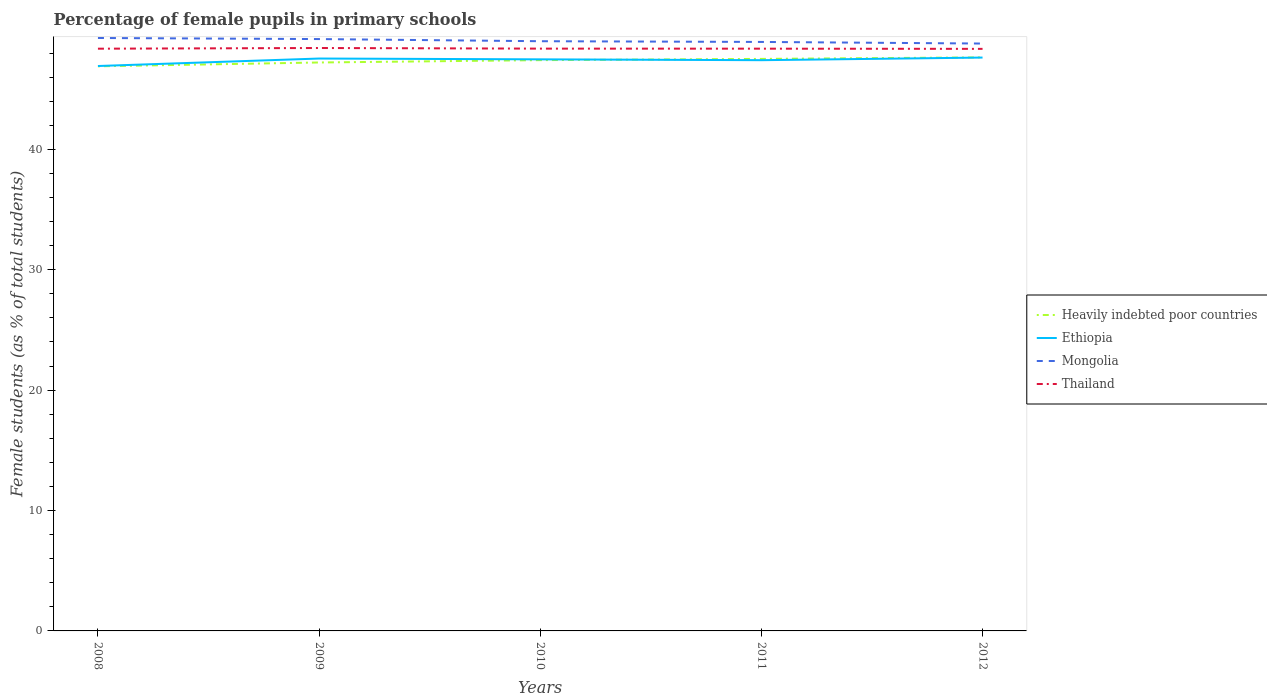Does the line corresponding to Heavily indebted poor countries intersect with the line corresponding to Ethiopia?
Offer a terse response. Yes. Across all years, what is the maximum percentage of female pupils in primary schools in Mongolia?
Make the answer very short. 48.79. In which year was the percentage of female pupils in primary schools in Heavily indebted poor countries maximum?
Make the answer very short. 2008. What is the total percentage of female pupils in primary schools in Heavily indebted poor countries in the graph?
Your answer should be compact. -0.32. What is the difference between the highest and the second highest percentage of female pupils in primary schools in Mongolia?
Offer a terse response. 0.46. What is the difference between the highest and the lowest percentage of female pupils in primary schools in Thailand?
Offer a terse response. 1. How many lines are there?
Provide a succinct answer. 4. Does the graph contain any zero values?
Make the answer very short. No. Does the graph contain grids?
Your response must be concise. No. How are the legend labels stacked?
Keep it short and to the point. Vertical. What is the title of the graph?
Offer a terse response. Percentage of female pupils in primary schools. What is the label or title of the Y-axis?
Provide a succinct answer. Female students (as % of total students). What is the Female students (as % of total students) in Heavily indebted poor countries in 2008?
Offer a very short reply. 46.89. What is the Female students (as % of total students) in Ethiopia in 2008?
Make the answer very short. 46.92. What is the Female students (as % of total students) in Mongolia in 2008?
Keep it short and to the point. 49.25. What is the Female students (as % of total students) of Thailand in 2008?
Offer a very short reply. 48.36. What is the Female students (as % of total students) in Heavily indebted poor countries in 2009?
Your answer should be compact. 47.21. What is the Female students (as % of total students) in Ethiopia in 2009?
Your answer should be very brief. 47.54. What is the Female students (as % of total students) in Mongolia in 2009?
Offer a terse response. 49.16. What is the Female students (as % of total students) of Thailand in 2009?
Offer a very short reply. 48.41. What is the Female students (as % of total students) of Heavily indebted poor countries in 2010?
Provide a short and direct response. 47.41. What is the Female students (as % of total students) of Ethiopia in 2010?
Give a very brief answer. 47.47. What is the Female students (as % of total students) of Mongolia in 2010?
Give a very brief answer. 48.98. What is the Female students (as % of total students) in Thailand in 2010?
Keep it short and to the point. 48.36. What is the Female students (as % of total students) in Heavily indebted poor countries in 2011?
Keep it short and to the point. 47.51. What is the Female students (as % of total students) in Ethiopia in 2011?
Make the answer very short. 47.4. What is the Female students (as % of total students) of Mongolia in 2011?
Offer a terse response. 48.92. What is the Female students (as % of total students) in Thailand in 2011?
Provide a short and direct response. 48.36. What is the Female students (as % of total students) in Heavily indebted poor countries in 2012?
Keep it short and to the point. 47.64. What is the Female students (as % of total students) in Ethiopia in 2012?
Your response must be concise. 47.62. What is the Female students (as % of total students) of Mongolia in 2012?
Offer a terse response. 48.79. What is the Female students (as % of total students) in Thailand in 2012?
Your response must be concise. 48.34. Across all years, what is the maximum Female students (as % of total students) of Heavily indebted poor countries?
Offer a terse response. 47.64. Across all years, what is the maximum Female students (as % of total students) in Ethiopia?
Your response must be concise. 47.62. Across all years, what is the maximum Female students (as % of total students) of Mongolia?
Give a very brief answer. 49.25. Across all years, what is the maximum Female students (as % of total students) of Thailand?
Provide a succinct answer. 48.41. Across all years, what is the minimum Female students (as % of total students) of Heavily indebted poor countries?
Your answer should be compact. 46.89. Across all years, what is the minimum Female students (as % of total students) of Ethiopia?
Offer a terse response. 46.92. Across all years, what is the minimum Female students (as % of total students) in Mongolia?
Keep it short and to the point. 48.79. Across all years, what is the minimum Female students (as % of total students) of Thailand?
Your answer should be compact. 48.34. What is the total Female students (as % of total students) in Heavily indebted poor countries in the graph?
Make the answer very short. 236.66. What is the total Female students (as % of total students) in Ethiopia in the graph?
Provide a short and direct response. 236.96. What is the total Female students (as % of total students) in Mongolia in the graph?
Make the answer very short. 245.09. What is the total Female students (as % of total students) of Thailand in the graph?
Your answer should be compact. 241.84. What is the difference between the Female students (as % of total students) in Heavily indebted poor countries in 2008 and that in 2009?
Provide a succinct answer. -0.32. What is the difference between the Female students (as % of total students) of Ethiopia in 2008 and that in 2009?
Keep it short and to the point. -0.62. What is the difference between the Female students (as % of total students) in Mongolia in 2008 and that in 2009?
Your answer should be very brief. 0.09. What is the difference between the Female students (as % of total students) in Thailand in 2008 and that in 2009?
Keep it short and to the point. -0.06. What is the difference between the Female students (as % of total students) of Heavily indebted poor countries in 2008 and that in 2010?
Offer a terse response. -0.51. What is the difference between the Female students (as % of total students) in Ethiopia in 2008 and that in 2010?
Make the answer very short. -0.55. What is the difference between the Female students (as % of total students) of Mongolia in 2008 and that in 2010?
Your response must be concise. 0.27. What is the difference between the Female students (as % of total students) of Thailand in 2008 and that in 2010?
Make the answer very short. -0.01. What is the difference between the Female students (as % of total students) of Heavily indebted poor countries in 2008 and that in 2011?
Provide a succinct answer. -0.62. What is the difference between the Female students (as % of total students) in Ethiopia in 2008 and that in 2011?
Provide a succinct answer. -0.48. What is the difference between the Female students (as % of total students) of Mongolia in 2008 and that in 2011?
Offer a terse response. 0.33. What is the difference between the Female students (as % of total students) in Thailand in 2008 and that in 2011?
Provide a short and direct response. -0. What is the difference between the Female students (as % of total students) in Heavily indebted poor countries in 2008 and that in 2012?
Provide a short and direct response. -0.74. What is the difference between the Female students (as % of total students) of Ethiopia in 2008 and that in 2012?
Offer a very short reply. -0.7. What is the difference between the Female students (as % of total students) of Mongolia in 2008 and that in 2012?
Your response must be concise. 0.46. What is the difference between the Female students (as % of total students) in Thailand in 2008 and that in 2012?
Keep it short and to the point. 0.01. What is the difference between the Female students (as % of total students) in Heavily indebted poor countries in 2009 and that in 2010?
Give a very brief answer. -0.19. What is the difference between the Female students (as % of total students) in Ethiopia in 2009 and that in 2010?
Your answer should be compact. 0.07. What is the difference between the Female students (as % of total students) in Mongolia in 2009 and that in 2010?
Keep it short and to the point. 0.18. What is the difference between the Female students (as % of total students) of Thailand in 2009 and that in 2010?
Your answer should be compact. 0.05. What is the difference between the Female students (as % of total students) in Heavily indebted poor countries in 2009 and that in 2011?
Your answer should be very brief. -0.3. What is the difference between the Female students (as % of total students) of Ethiopia in 2009 and that in 2011?
Make the answer very short. 0.14. What is the difference between the Female students (as % of total students) in Mongolia in 2009 and that in 2011?
Offer a terse response. 0.24. What is the difference between the Female students (as % of total students) in Thailand in 2009 and that in 2011?
Provide a succinct answer. 0.05. What is the difference between the Female students (as % of total students) of Heavily indebted poor countries in 2009 and that in 2012?
Your answer should be very brief. -0.42. What is the difference between the Female students (as % of total students) of Ethiopia in 2009 and that in 2012?
Ensure brevity in your answer.  -0.08. What is the difference between the Female students (as % of total students) in Mongolia in 2009 and that in 2012?
Give a very brief answer. 0.37. What is the difference between the Female students (as % of total students) in Thailand in 2009 and that in 2012?
Your response must be concise. 0.07. What is the difference between the Female students (as % of total students) in Heavily indebted poor countries in 2010 and that in 2011?
Offer a very short reply. -0.1. What is the difference between the Female students (as % of total students) of Ethiopia in 2010 and that in 2011?
Your response must be concise. 0.07. What is the difference between the Female students (as % of total students) of Thailand in 2010 and that in 2011?
Your answer should be compact. 0. What is the difference between the Female students (as % of total students) of Heavily indebted poor countries in 2010 and that in 2012?
Keep it short and to the point. -0.23. What is the difference between the Female students (as % of total students) of Ethiopia in 2010 and that in 2012?
Provide a succinct answer. -0.15. What is the difference between the Female students (as % of total students) of Mongolia in 2010 and that in 2012?
Provide a succinct answer. 0.19. What is the difference between the Female students (as % of total students) in Thailand in 2010 and that in 2012?
Your response must be concise. 0.02. What is the difference between the Female students (as % of total students) of Heavily indebted poor countries in 2011 and that in 2012?
Offer a very short reply. -0.13. What is the difference between the Female students (as % of total students) in Ethiopia in 2011 and that in 2012?
Keep it short and to the point. -0.22. What is the difference between the Female students (as % of total students) in Mongolia in 2011 and that in 2012?
Your answer should be compact. 0.13. What is the difference between the Female students (as % of total students) in Thailand in 2011 and that in 2012?
Make the answer very short. 0.02. What is the difference between the Female students (as % of total students) of Heavily indebted poor countries in 2008 and the Female students (as % of total students) of Ethiopia in 2009?
Give a very brief answer. -0.65. What is the difference between the Female students (as % of total students) in Heavily indebted poor countries in 2008 and the Female students (as % of total students) in Mongolia in 2009?
Make the answer very short. -2.26. What is the difference between the Female students (as % of total students) of Heavily indebted poor countries in 2008 and the Female students (as % of total students) of Thailand in 2009?
Offer a very short reply. -1.52. What is the difference between the Female students (as % of total students) in Ethiopia in 2008 and the Female students (as % of total students) in Mongolia in 2009?
Provide a short and direct response. -2.24. What is the difference between the Female students (as % of total students) of Ethiopia in 2008 and the Female students (as % of total students) of Thailand in 2009?
Your answer should be compact. -1.5. What is the difference between the Female students (as % of total students) in Mongolia in 2008 and the Female students (as % of total students) in Thailand in 2009?
Your answer should be compact. 0.83. What is the difference between the Female students (as % of total students) in Heavily indebted poor countries in 2008 and the Female students (as % of total students) in Ethiopia in 2010?
Offer a very short reply. -0.58. What is the difference between the Female students (as % of total students) in Heavily indebted poor countries in 2008 and the Female students (as % of total students) in Mongolia in 2010?
Your response must be concise. -2.08. What is the difference between the Female students (as % of total students) of Heavily indebted poor countries in 2008 and the Female students (as % of total students) of Thailand in 2010?
Keep it short and to the point. -1.47. What is the difference between the Female students (as % of total students) of Ethiopia in 2008 and the Female students (as % of total students) of Mongolia in 2010?
Provide a succinct answer. -2.06. What is the difference between the Female students (as % of total students) of Ethiopia in 2008 and the Female students (as % of total students) of Thailand in 2010?
Provide a succinct answer. -1.44. What is the difference between the Female students (as % of total students) of Mongolia in 2008 and the Female students (as % of total students) of Thailand in 2010?
Give a very brief answer. 0.88. What is the difference between the Female students (as % of total students) in Heavily indebted poor countries in 2008 and the Female students (as % of total students) in Ethiopia in 2011?
Offer a very short reply. -0.51. What is the difference between the Female students (as % of total students) in Heavily indebted poor countries in 2008 and the Female students (as % of total students) in Mongolia in 2011?
Provide a short and direct response. -2.02. What is the difference between the Female students (as % of total students) in Heavily indebted poor countries in 2008 and the Female students (as % of total students) in Thailand in 2011?
Offer a terse response. -1.47. What is the difference between the Female students (as % of total students) of Ethiopia in 2008 and the Female students (as % of total students) of Mongolia in 2011?
Your answer should be very brief. -2. What is the difference between the Female students (as % of total students) of Ethiopia in 2008 and the Female students (as % of total students) of Thailand in 2011?
Give a very brief answer. -1.44. What is the difference between the Female students (as % of total students) of Mongolia in 2008 and the Female students (as % of total students) of Thailand in 2011?
Your answer should be compact. 0.89. What is the difference between the Female students (as % of total students) of Heavily indebted poor countries in 2008 and the Female students (as % of total students) of Ethiopia in 2012?
Ensure brevity in your answer.  -0.73. What is the difference between the Female students (as % of total students) in Heavily indebted poor countries in 2008 and the Female students (as % of total students) in Mongolia in 2012?
Offer a very short reply. -1.89. What is the difference between the Female students (as % of total students) of Heavily indebted poor countries in 2008 and the Female students (as % of total students) of Thailand in 2012?
Your response must be concise. -1.45. What is the difference between the Female students (as % of total students) of Ethiopia in 2008 and the Female students (as % of total students) of Mongolia in 2012?
Make the answer very short. -1.87. What is the difference between the Female students (as % of total students) of Ethiopia in 2008 and the Female students (as % of total students) of Thailand in 2012?
Your answer should be very brief. -1.42. What is the difference between the Female students (as % of total students) in Mongolia in 2008 and the Female students (as % of total students) in Thailand in 2012?
Keep it short and to the point. 0.9. What is the difference between the Female students (as % of total students) in Heavily indebted poor countries in 2009 and the Female students (as % of total students) in Ethiopia in 2010?
Make the answer very short. -0.26. What is the difference between the Female students (as % of total students) of Heavily indebted poor countries in 2009 and the Female students (as % of total students) of Mongolia in 2010?
Give a very brief answer. -1.77. What is the difference between the Female students (as % of total students) of Heavily indebted poor countries in 2009 and the Female students (as % of total students) of Thailand in 2010?
Your response must be concise. -1.15. What is the difference between the Female students (as % of total students) in Ethiopia in 2009 and the Female students (as % of total students) in Mongolia in 2010?
Your answer should be very brief. -1.44. What is the difference between the Female students (as % of total students) of Ethiopia in 2009 and the Female students (as % of total students) of Thailand in 2010?
Your answer should be compact. -0.82. What is the difference between the Female students (as % of total students) of Mongolia in 2009 and the Female students (as % of total students) of Thailand in 2010?
Provide a short and direct response. 0.79. What is the difference between the Female students (as % of total students) of Heavily indebted poor countries in 2009 and the Female students (as % of total students) of Ethiopia in 2011?
Your answer should be very brief. -0.19. What is the difference between the Female students (as % of total students) in Heavily indebted poor countries in 2009 and the Female students (as % of total students) in Mongolia in 2011?
Ensure brevity in your answer.  -1.71. What is the difference between the Female students (as % of total students) in Heavily indebted poor countries in 2009 and the Female students (as % of total students) in Thailand in 2011?
Your answer should be very brief. -1.15. What is the difference between the Female students (as % of total students) of Ethiopia in 2009 and the Female students (as % of total students) of Mongolia in 2011?
Your response must be concise. -1.38. What is the difference between the Female students (as % of total students) in Ethiopia in 2009 and the Female students (as % of total students) in Thailand in 2011?
Make the answer very short. -0.82. What is the difference between the Female students (as % of total students) in Mongolia in 2009 and the Female students (as % of total students) in Thailand in 2011?
Offer a terse response. 0.8. What is the difference between the Female students (as % of total students) of Heavily indebted poor countries in 2009 and the Female students (as % of total students) of Ethiopia in 2012?
Your answer should be very brief. -0.41. What is the difference between the Female students (as % of total students) of Heavily indebted poor countries in 2009 and the Female students (as % of total students) of Mongolia in 2012?
Your answer should be compact. -1.57. What is the difference between the Female students (as % of total students) in Heavily indebted poor countries in 2009 and the Female students (as % of total students) in Thailand in 2012?
Offer a very short reply. -1.13. What is the difference between the Female students (as % of total students) of Ethiopia in 2009 and the Female students (as % of total students) of Mongolia in 2012?
Ensure brevity in your answer.  -1.25. What is the difference between the Female students (as % of total students) of Ethiopia in 2009 and the Female students (as % of total students) of Thailand in 2012?
Ensure brevity in your answer.  -0.8. What is the difference between the Female students (as % of total students) in Mongolia in 2009 and the Female students (as % of total students) in Thailand in 2012?
Your answer should be compact. 0.81. What is the difference between the Female students (as % of total students) of Heavily indebted poor countries in 2010 and the Female students (as % of total students) of Ethiopia in 2011?
Your response must be concise. 0. What is the difference between the Female students (as % of total students) in Heavily indebted poor countries in 2010 and the Female students (as % of total students) in Mongolia in 2011?
Provide a succinct answer. -1.51. What is the difference between the Female students (as % of total students) in Heavily indebted poor countries in 2010 and the Female students (as % of total students) in Thailand in 2011?
Your response must be concise. -0.95. What is the difference between the Female students (as % of total students) in Ethiopia in 2010 and the Female students (as % of total students) in Mongolia in 2011?
Ensure brevity in your answer.  -1.45. What is the difference between the Female students (as % of total students) of Ethiopia in 2010 and the Female students (as % of total students) of Thailand in 2011?
Your answer should be very brief. -0.89. What is the difference between the Female students (as % of total students) of Mongolia in 2010 and the Female students (as % of total students) of Thailand in 2011?
Your response must be concise. 0.62. What is the difference between the Female students (as % of total students) in Heavily indebted poor countries in 2010 and the Female students (as % of total students) in Ethiopia in 2012?
Give a very brief answer. -0.21. What is the difference between the Female students (as % of total students) of Heavily indebted poor countries in 2010 and the Female students (as % of total students) of Mongolia in 2012?
Your answer should be very brief. -1.38. What is the difference between the Female students (as % of total students) of Heavily indebted poor countries in 2010 and the Female students (as % of total students) of Thailand in 2012?
Give a very brief answer. -0.94. What is the difference between the Female students (as % of total students) in Ethiopia in 2010 and the Female students (as % of total students) in Mongolia in 2012?
Give a very brief answer. -1.31. What is the difference between the Female students (as % of total students) in Ethiopia in 2010 and the Female students (as % of total students) in Thailand in 2012?
Offer a terse response. -0.87. What is the difference between the Female students (as % of total students) in Mongolia in 2010 and the Female students (as % of total students) in Thailand in 2012?
Keep it short and to the point. 0.64. What is the difference between the Female students (as % of total students) of Heavily indebted poor countries in 2011 and the Female students (as % of total students) of Ethiopia in 2012?
Give a very brief answer. -0.11. What is the difference between the Female students (as % of total students) in Heavily indebted poor countries in 2011 and the Female students (as % of total students) in Mongolia in 2012?
Your answer should be very brief. -1.28. What is the difference between the Female students (as % of total students) in Heavily indebted poor countries in 2011 and the Female students (as % of total students) in Thailand in 2012?
Provide a succinct answer. -0.83. What is the difference between the Female students (as % of total students) of Ethiopia in 2011 and the Female students (as % of total students) of Mongolia in 2012?
Your answer should be very brief. -1.38. What is the difference between the Female students (as % of total students) of Ethiopia in 2011 and the Female students (as % of total students) of Thailand in 2012?
Keep it short and to the point. -0.94. What is the difference between the Female students (as % of total students) of Mongolia in 2011 and the Female students (as % of total students) of Thailand in 2012?
Make the answer very short. 0.58. What is the average Female students (as % of total students) in Heavily indebted poor countries per year?
Ensure brevity in your answer.  47.33. What is the average Female students (as % of total students) of Ethiopia per year?
Offer a very short reply. 47.39. What is the average Female students (as % of total students) in Mongolia per year?
Keep it short and to the point. 49.02. What is the average Female students (as % of total students) of Thailand per year?
Your answer should be very brief. 48.37. In the year 2008, what is the difference between the Female students (as % of total students) in Heavily indebted poor countries and Female students (as % of total students) in Ethiopia?
Your answer should be compact. -0.02. In the year 2008, what is the difference between the Female students (as % of total students) of Heavily indebted poor countries and Female students (as % of total students) of Mongolia?
Keep it short and to the point. -2.35. In the year 2008, what is the difference between the Female students (as % of total students) in Heavily indebted poor countries and Female students (as % of total students) in Thailand?
Keep it short and to the point. -1.46. In the year 2008, what is the difference between the Female students (as % of total students) in Ethiopia and Female students (as % of total students) in Mongolia?
Your response must be concise. -2.33. In the year 2008, what is the difference between the Female students (as % of total students) in Ethiopia and Female students (as % of total students) in Thailand?
Provide a succinct answer. -1.44. In the year 2008, what is the difference between the Female students (as % of total students) of Mongolia and Female students (as % of total students) of Thailand?
Keep it short and to the point. 0.89. In the year 2009, what is the difference between the Female students (as % of total students) of Heavily indebted poor countries and Female students (as % of total students) of Ethiopia?
Provide a succinct answer. -0.33. In the year 2009, what is the difference between the Female students (as % of total students) of Heavily indebted poor countries and Female students (as % of total students) of Mongolia?
Offer a very short reply. -1.94. In the year 2009, what is the difference between the Female students (as % of total students) of Heavily indebted poor countries and Female students (as % of total students) of Thailand?
Your answer should be compact. -1.2. In the year 2009, what is the difference between the Female students (as % of total students) in Ethiopia and Female students (as % of total students) in Mongolia?
Provide a short and direct response. -1.62. In the year 2009, what is the difference between the Female students (as % of total students) of Ethiopia and Female students (as % of total students) of Thailand?
Keep it short and to the point. -0.87. In the year 2009, what is the difference between the Female students (as % of total students) in Mongolia and Female students (as % of total students) in Thailand?
Give a very brief answer. 0.74. In the year 2010, what is the difference between the Female students (as % of total students) of Heavily indebted poor countries and Female students (as % of total students) of Ethiopia?
Your answer should be very brief. -0.07. In the year 2010, what is the difference between the Female students (as % of total students) of Heavily indebted poor countries and Female students (as % of total students) of Mongolia?
Your response must be concise. -1.57. In the year 2010, what is the difference between the Female students (as % of total students) of Heavily indebted poor countries and Female students (as % of total students) of Thailand?
Provide a succinct answer. -0.96. In the year 2010, what is the difference between the Female students (as % of total students) of Ethiopia and Female students (as % of total students) of Mongolia?
Keep it short and to the point. -1.51. In the year 2010, what is the difference between the Female students (as % of total students) of Ethiopia and Female students (as % of total students) of Thailand?
Make the answer very short. -0.89. In the year 2010, what is the difference between the Female students (as % of total students) in Mongolia and Female students (as % of total students) in Thailand?
Your answer should be compact. 0.62. In the year 2011, what is the difference between the Female students (as % of total students) of Heavily indebted poor countries and Female students (as % of total students) of Ethiopia?
Make the answer very short. 0.11. In the year 2011, what is the difference between the Female students (as % of total students) in Heavily indebted poor countries and Female students (as % of total students) in Mongolia?
Your answer should be very brief. -1.41. In the year 2011, what is the difference between the Female students (as % of total students) in Heavily indebted poor countries and Female students (as % of total students) in Thailand?
Offer a very short reply. -0.85. In the year 2011, what is the difference between the Female students (as % of total students) in Ethiopia and Female students (as % of total students) in Mongolia?
Keep it short and to the point. -1.52. In the year 2011, what is the difference between the Female students (as % of total students) of Ethiopia and Female students (as % of total students) of Thailand?
Offer a terse response. -0.96. In the year 2011, what is the difference between the Female students (as % of total students) in Mongolia and Female students (as % of total students) in Thailand?
Keep it short and to the point. 0.56. In the year 2012, what is the difference between the Female students (as % of total students) of Heavily indebted poor countries and Female students (as % of total students) of Ethiopia?
Your response must be concise. 0.02. In the year 2012, what is the difference between the Female students (as % of total students) in Heavily indebted poor countries and Female students (as % of total students) in Mongolia?
Keep it short and to the point. -1.15. In the year 2012, what is the difference between the Female students (as % of total students) of Heavily indebted poor countries and Female students (as % of total students) of Thailand?
Your answer should be compact. -0.71. In the year 2012, what is the difference between the Female students (as % of total students) in Ethiopia and Female students (as % of total students) in Mongolia?
Offer a very short reply. -1.16. In the year 2012, what is the difference between the Female students (as % of total students) in Ethiopia and Female students (as % of total students) in Thailand?
Keep it short and to the point. -0.72. In the year 2012, what is the difference between the Female students (as % of total students) of Mongolia and Female students (as % of total students) of Thailand?
Offer a terse response. 0.44. What is the ratio of the Female students (as % of total students) in Heavily indebted poor countries in 2008 to that in 2009?
Provide a succinct answer. 0.99. What is the ratio of the Female students (as % of total students) of Ethiopia in 2008 to that in 2009?
Your response must be concise. 0.99. What is the ratio of the Female students (as % of total students) of Thailand in 2008 to that in 2009?
Your answer should be very brief. 1. What is the ratio of the Female students (as % of total students) of Heavily indebted poor countries in 2008 to that in 2010?
Ensure brevity in your answer.  0.99. What is the ratio of the Female students (as % of total students) of Ethiopia in 2008 to that in 2010?
Make the answer very short. 0.99. What is the ratio of the Female students (as % of total students) of Thailand in 2008 to that in 2010?
Your answer should be compact. 1. What is the ratio of the Female students (as % of total students) of Thailand in 2008 to that in 2011?
Make the answer very short. 1. What is the ratio of the Female students (as % of total students) of Heavily indebted poor countries in 2008 to that in 2012?
Make the answer very short. 0.98. What is the ratio of the Female students (as % of total students) of Mongolia in 2008 to that in 2012?
Give a very brief answer. 1.01. What is the ratio of the Female students (as % of total students) in Thailand in 2008 to that in 2012?
Make the answer very short. 1. What is the ratio of the Female students (as % of total students) in Thailand in 2009 to that in 2010?
Your response must be concise. 1. What is the ratio of the Female students (as % of total students) of Mongolia in 2009 to that in 2011?
Your answer should be very brief. 1. What is the ratio of the Female students (as % of total students) in Thailand in 2009 to that in 2011?
Your answer should be very brief. 1. What is the ratio of the Female students (as % of total students) in Mongolia in 2009 to that in 2012?
Offer a terse response. 1.01. What is the ratio of the Female students (as % of total students) of Heavily indebted poor countries in 2010 to that in 2011?
Make the answer very short. 1. What is the ratio of the Female students (as % of total students) of Ethiopia in 2010 to that in 2011?
Make the answer very short. 1. What is the ratio of the Female students (as % of total students) in Mongolia in 2010 to that in 2011?
Your answer should be compact. 1. What is the ratio of the Female students (as % of total students) of Heavily indebted poor countries in 2010 to that in 2012?
Your answer should be very brief. 1. What is the ratio of the Female students (as % of total students) of Thailand in 2010 to that in 2012?
Your response must be concise. 1. What is the ratio of the Female students (as % of total students) of Heavily indebted poor countries in 2011 to that in 2012?
Ensure brevity in your answer.  1. What is the difference between the highest and the second highest Female students (as % of total students) in Heavily indebted poor countries?
Provide a succinct answer. 0.13. What is the difference between the highest and the second highest Female students (as % of total students) of Ethiopia?
Make the answer very short. 0.08. What is the difference between the highest and the second highest Female students (as % of total students) in Mongolia?
Make the answer very short. 0.09. What is the difference between the highest and the second highest Female students (as % of total students) in Thailand?
Your response must be concise. 0.05. What is the difference between the highest and the lowest Female students (as % of total students) in Heavily indebted poor countries?
Offer a terse response. 0.74. What is the difference between the highest and the lowest Female students (as % of total students) in Ethiopia?
Provide a short and direct response. 0.7. What is the difference between the highest and the lowest Female students (as % of total students) in Mongolia?
Offer a terse response. 0.46. What is the difference between the highest and the lowest Female students (as % of total students) in Thailand?
Provide a short and direct response. 0.07. 